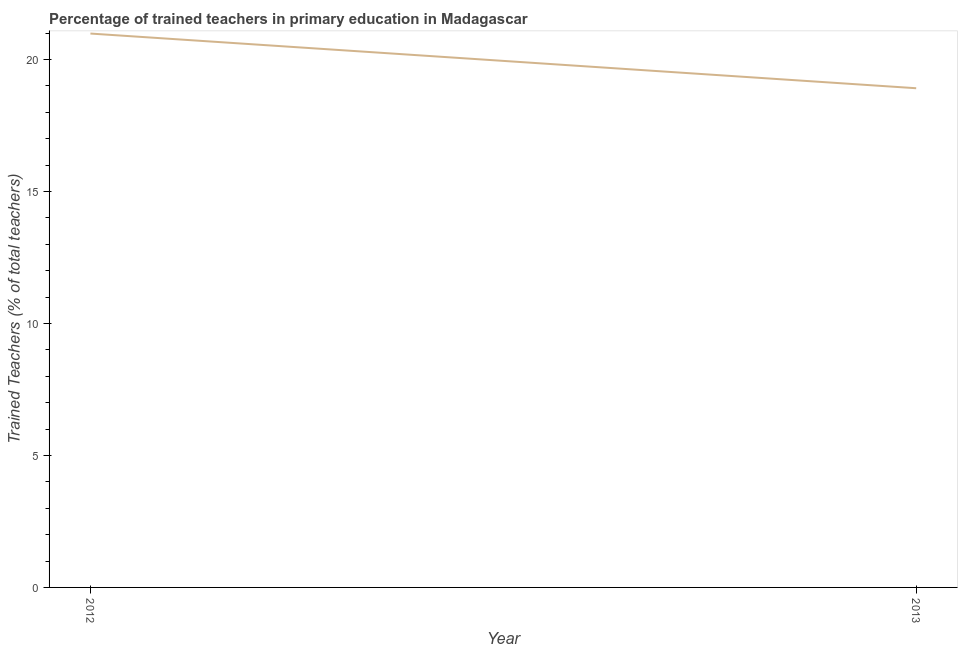What is the percentage of trained teachers in 2013?
Keep it short and to the point. 18.91. Across all years, what is the maximum percentage of trained teachers?
Offer a terse response. 20.99. Across all years, what is the minimum percentage of trained teachers?
Offer a terse response. 18.91. In which year was the percentage of trained teachers maximum?
Offer a very short reply. 2012. In which year was the percentage of trained teachers minimum?
Ensure brevity in your answer.  2013. What is the sum of the percentage of trained teachers?
Make the answer very short. 39.9. What is the difference between the percentage of trained teachers in 2012 and 2013?
Your response must be concise. 2.07. What is the average percentage of trained teachers per year?
Your response must be concise. 19.95. What is the median percentage of trained teachers?
Keep it short and to the point. 19.95. In how many years, is the percentage of trained teachers greater than 20 %?
Give a very brief answer. 1. Do a majority of the years between 2013 and 2012 (inclusive) have percentage of trained teachers greater than 14 %?
Ensure brevity in your answer.  No. What is the ratio of the percentage of trained teachers in 2012 to that in 2013?
Make the answer very short. 1.11. In how many years, is the percentage of trained teachers greater than the average percentage of trained teachers taken over all years?
Offer a terse response. 1. Does the graph contain grids?
Make the answer very short. No. What is the title of the graph?
Make the answer very short. Percentage of trained teachers in primary education in Madagascar. What is the label or title of the X-axis?
Make the answer very short. Year. What is the label or title of the Y-axis?
Your answer should be compact. Trained Teachers (% of total teachers). What is the Trained Teachers (% of total teachers) of 2012?
Ensure brevity in your answer.  20.99. What is the Trained Teachers (% of total teachers) of 2013?
Ensure brevity in your answer.  18.91. What is the difference between the Trained Teachers (% of total teachers) in 2012 and 2013?
Your response must be concise. 2.07. What is the ratio of the Trained Teachers (% of total teachers) in 2012 to that in 2013?
Offer a terse response. 1.11. 